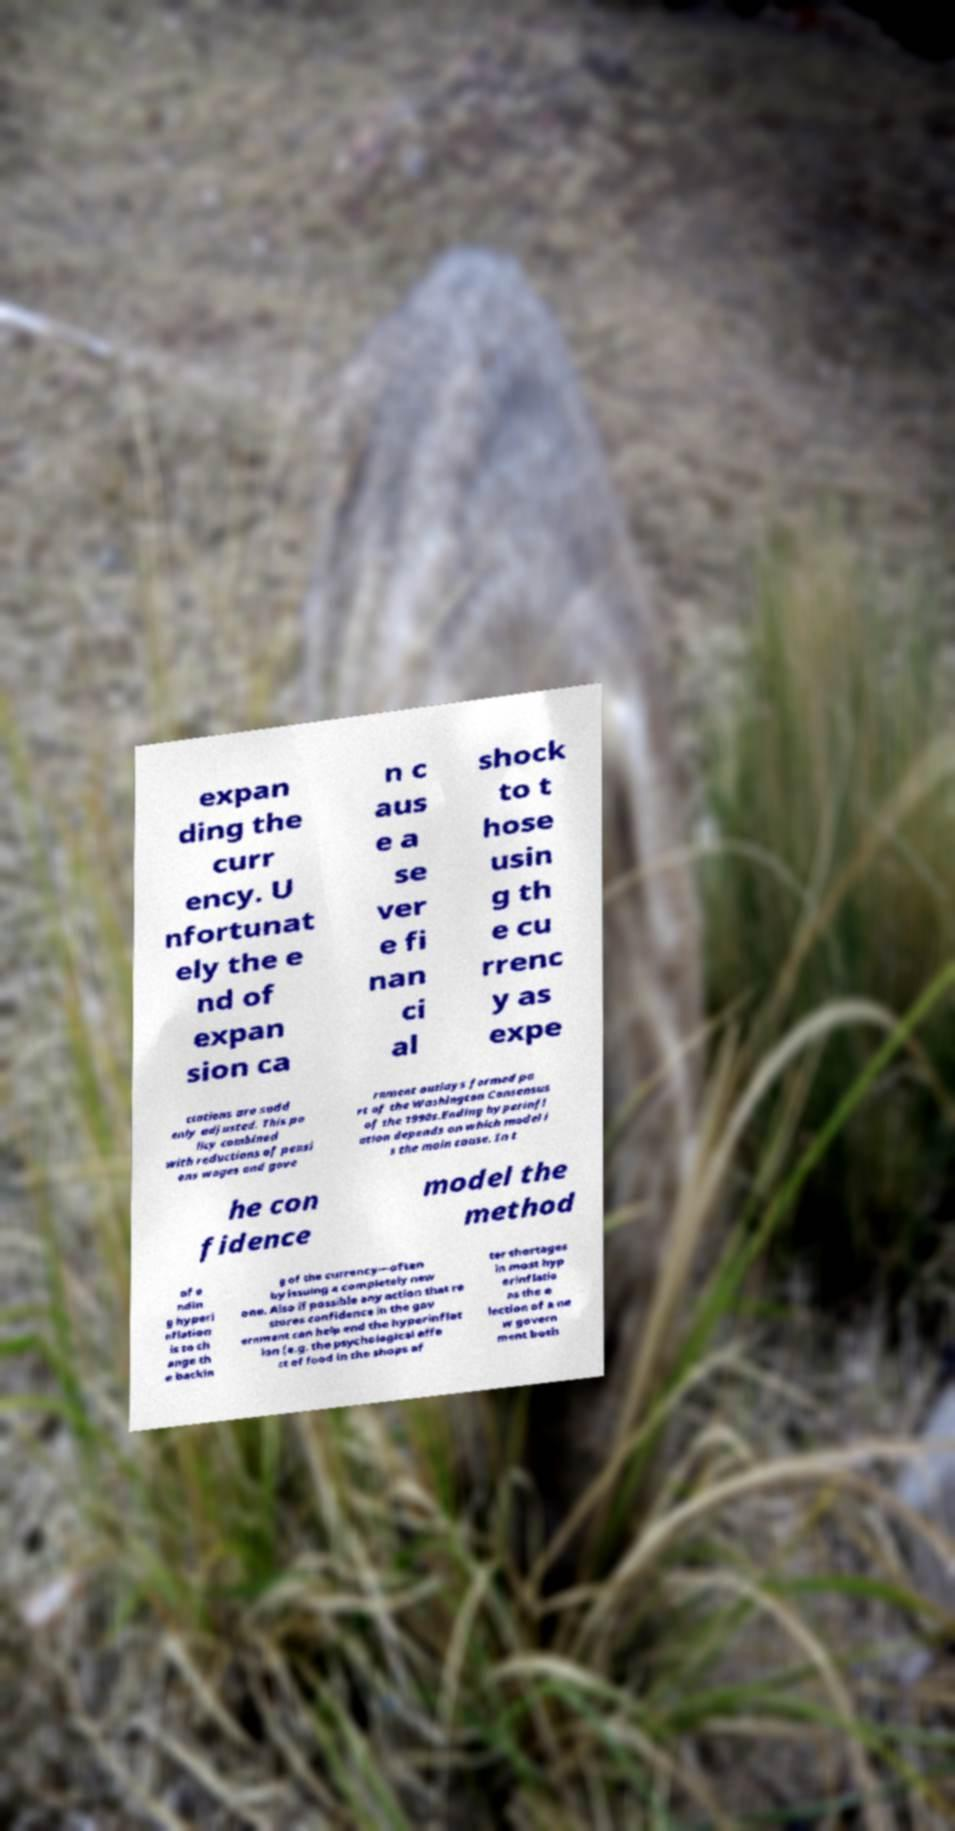Could you extract and type out the text from this image? expan ding the curr ency. U nfortunat ely the e nd of expan sion ca n c aus e a se ver e fi nan ci al shock to t hose usin g th e cu rrenc y as expe ctations are sudd enly adjusted. This po licy combined with reductions of pensi ons wages and gove rnment outlays formed pa rt of the Washington Consensus of the 1990s.Ending hyperinfl ation depends on which model i s the main cause. In t he con fidence model the method of e ndin g hyperi nflation is to ch ange th e backin g of the currency—often by issuing a completely new one. Also if possible any action that re stores confidence in the gov ernment can help end the hyperinflat ion (e.g. the psychological effe ct of food in the shops af ter shortages in most hyp erinflatio ns the e lection of a ne w govern ment both 